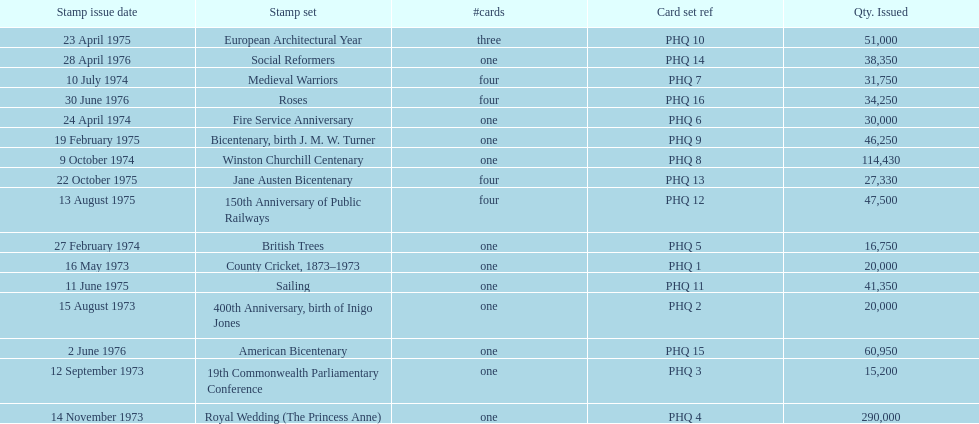Which year had the most stamps issued? 1973. 